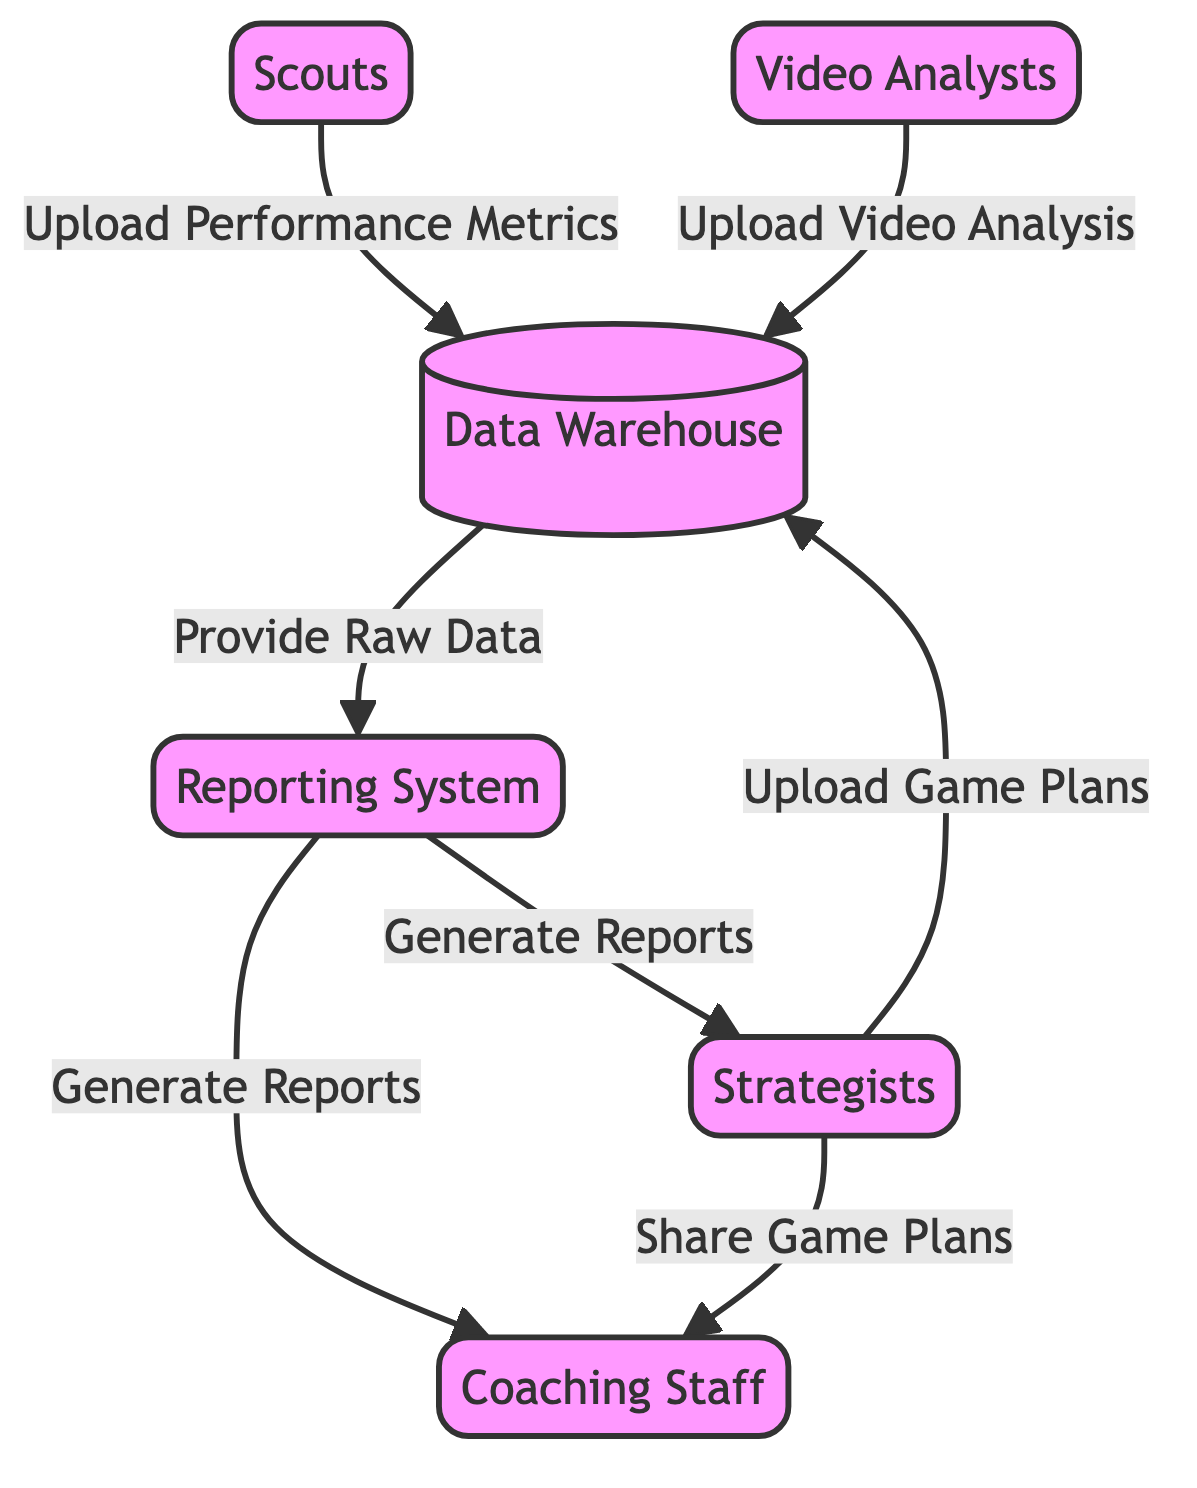What role do video analysts play? Video analysts analyze game footage to extract key plays and tendencies, according to their labeled role in the diagram.
Answer: Analyze game footage How many nodes are present in the diagram? By counting the distinct nodes listed in the data input, there are a total of six nodes: scouts, video analysts, strategists, coaching staff, data warehouse, and reporting system.
Answer: 6 What do scouts upload to the data warehouse? The edge labeled "Upload Performance Metrics" indicates that scouts upload performance metrics to the data warehouse.
Answer: Performance Metrics Which nodes receive reports from the reporting system? The edges labeled "Generate Reports" show that both strategists and coaching staff receive reports from the reporting system, as indicated in the connections.
Answer: Strategists and Coaching Staff What is the main purpose of the data warehouse? The labeled role for the data warehouse states that it serves as a central repository for all collected data, which defines its primary purpose clearly.
Answer: Central repository From which node does the reporting system receive raw data? The edge labeled "Provide Raw Data" indicates that the reporting system receives raw data from the data warehouse, establishing the flow of information.
Answer: Data Warehouse Which group shares game plans with the coaching staff? The edge labeled "Share Game Plans" specifies that strategists are the group that shares game plans with the coaching staff, based on that connection.
Answer: Strategists How do video analysts contribute to the data analytics process? By analyzing game footage and uploading video analysis to the data warehouse, video analysts contribute significantly to the overall data analytics process as indicated in their role description.
Answer: Upload video analysis What is the connection between strategists and coaching staff? The connection is established through the edge labeled "Share Game Plans," indicating that strategists share game plans with the coaching staff.
Answer: Share Game Plans 